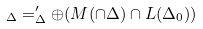<formula> <loc_0><loc_0><loc_500><loc_500>_ { \Delta } = ^ { \prime } _ { \Delta } \oplus ( M ( \cap \Delta ) \cap \L L ( \Delta _ { 0 } ) )</formula> 